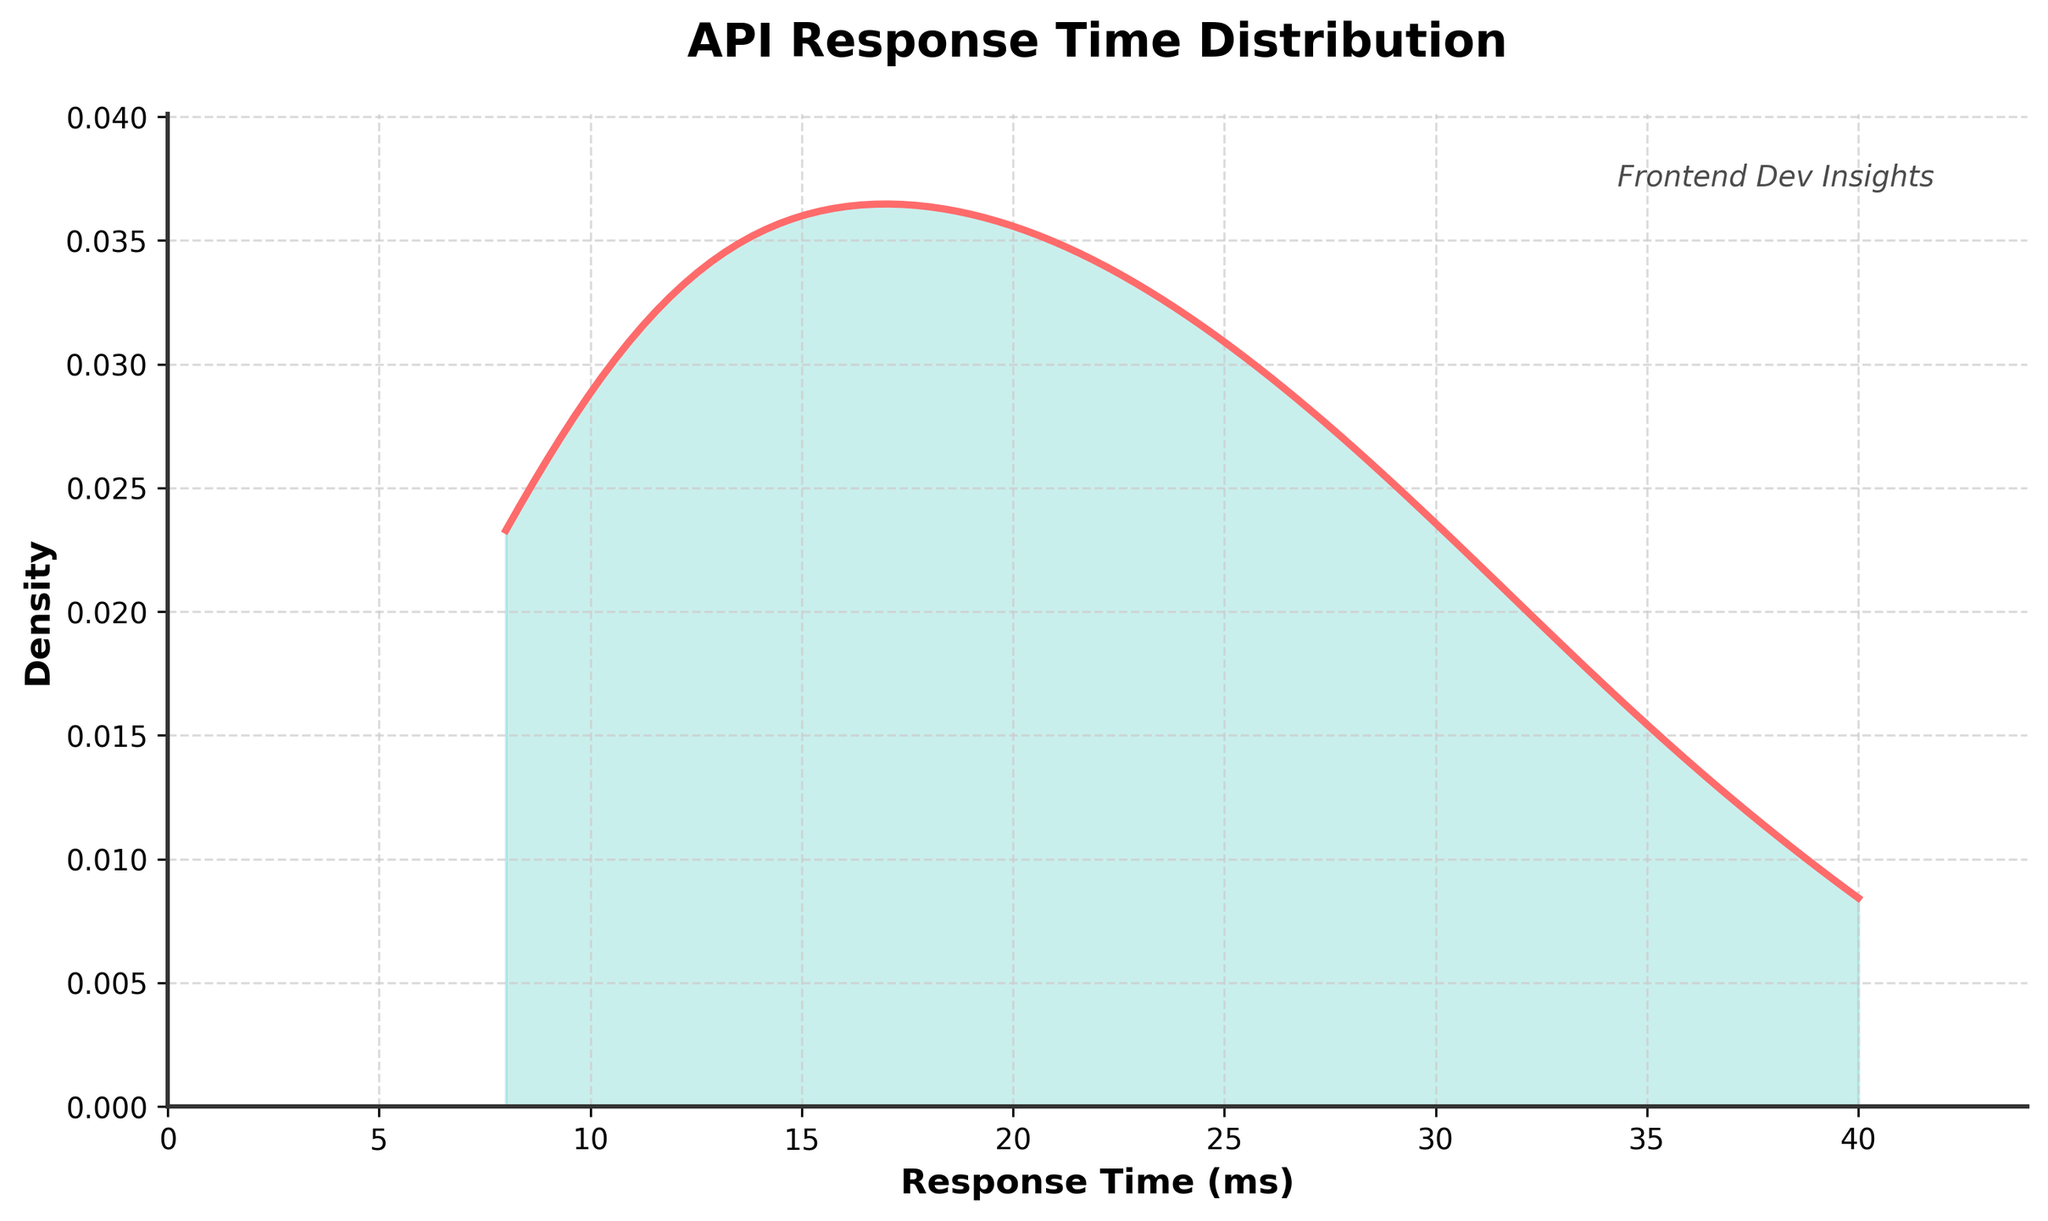What is the title of the figure? The title is usually found at the top of the figure in bold text.
Answer: API Response Time Distribution What kind of plot is presented in the figure? We can observe that the plot shows the density of response times which indicates that it is a density plot.
Answer: Density plot Which axis represents the response time, and which one represents the density? The x-axis is labeled "Response Time (ms)" and the y-axis is labeled "Density".
Answer: x-axis: Response Time (ms), y-axis: Density What is the color used for the density curve? The curve color can be identified visually.
Answer: Red (represented visually as #FF6B6B) Between which two values does the peak density occur? Look for the highest point on the curve and check its corresponding x-axis values.
Answer: Around 10 ms and 20 ms What is the range of response times plotted? The response times range from the minimum to the maximum value on the x-axis.
Answer: 8 ms to 40 ms Identify the API endpoint with the highest response time. From the data, the highest response time is 40 ms, which corresponds to the endpoint /order/history.
Answer: /order/history Is the response time distribution skewed more to the left or to the right? Check the distribution shape; if it tails off more to the right, it’s right-skewed, implying longer response times are less frequent.
Answer: Skewed to the right What is the approximate density value at a response time of 30 ms? Locate the response time of 30 ms on the x-axis and find the density value on the y-axis at this point.
Answer: Approximately 0.03 How does the density of response times change as we move from 10 ms to 20 ms? Observe the shape and height of the density curve between these values and note whether it increases, decreases, or stays constant.
Answer: It increases and then slightly decreases Which response time has a higher density: 15 ms or 25 ms? Compare the density values on the y-axis for the response times 15 ms and 25 ms.
Answer: 15 ms 